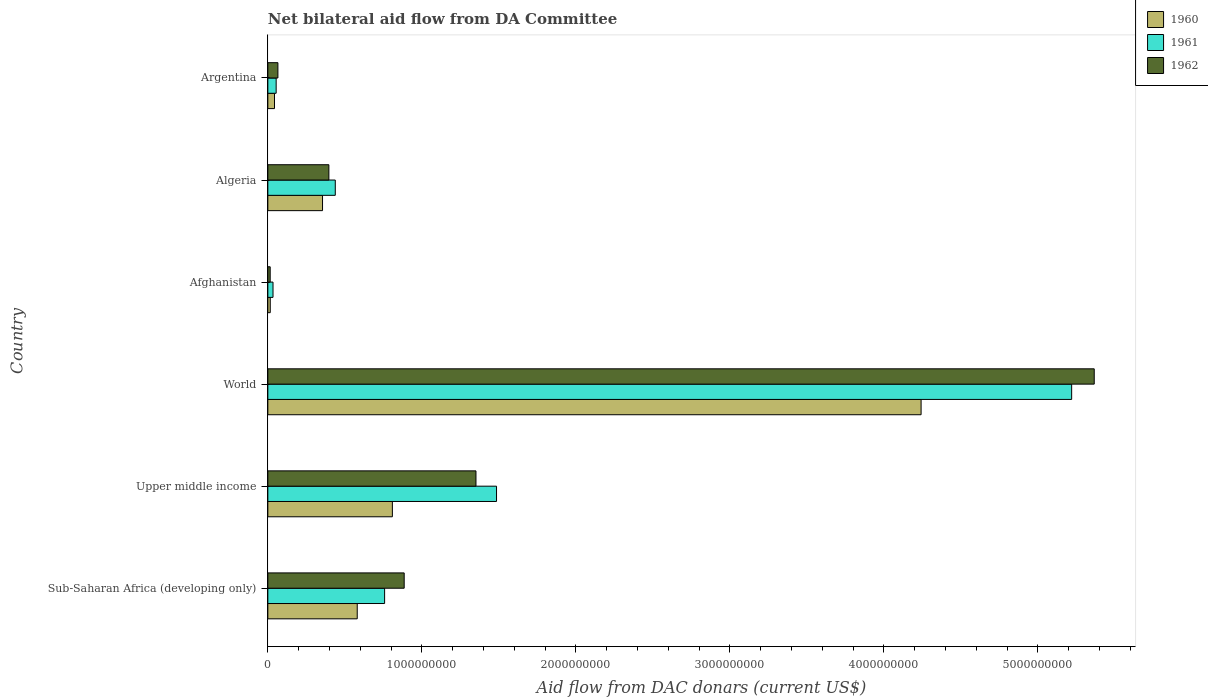How many groups of bars are there?
Give a very brief answer. 6. Are the number of bars per tick equal to the number of legend labels?
Your response must be concise. Yes. Are the number of bars on each tick of the Y-axis equal?
Provide a succinct answer. Yes. How many bars are there on the 6th tick from the top?
Make the answer very short. 3. How many bars are there on the 4th tick from the bottom?
Give a very brief answer. 3. What is the label of the 3rd group of bars from the top?
Provide a short and direct response. Afghanistan. In how many cases, is the number of bars for a given country not equal to the number of legend labels?
Make the answer very short. 0. What is the aid flow in in 1962 in Argentina?
Your answer should be very brief. 6.53e+07. Across all countries, what is the maximum aid flow in in 1962?
Give a very brief answer. 5.37e+09. Across all countries, what is the minimum aid flow in in 1962?
Offer a terse response. 1.53e+07. In which country was the aid flow in in 1960 maximum?
Your answer should be very brief. World. In which country was the aid flow in in 1960 minimum?
Provide a succinct answer. Afghanistan. What is the total aid flow in in 1960 in the graph?
Offer a terse response. 6.04e+09. What is the difference between the aid flow in in 1961 in Afghanistan and that in Argentina?
Your answer should be compact. -2.04e+07. What is the difference between the aid flow in in 1960 in Algeria and the aid flow in in 1961 in Afghanistan?
Provide a short and direct response. 3.22e+08. What is the average aid flow in in 1961 per country?
Your response must be concise. 1.33e+09. What is the difference between the aid flow in in 1960 and aid flow in in 1962 in Upper middle income?
Give a very brief answer. -5.43e+08. In how many countries, is the aid flow in in 1960 greater than 5000000000 US$?
Ensure brevity in your answer.  0. What is the ratio of the aid flow in in 1962 in Afghanistan to that in Upper middle income?
Offer a terse response. 0.01. Is the aid flow in in 1960 in Afghanistan less than that in Sub-Saharan Africa (developing only)?
Your response must be concise. Yes. What is the difference between the highest and the second highest aid flow in in 1961?
Ensure brevity in your answer.  3.73e+09. What is the difference between the highest and the lowest aid flow in in 1960?
Ensure brevity in your answer.  4.23e+09. Is the sum of the aid flow in in 1962 in Sub-Saharan Africa (developing only) and World greater than the maximum aid flow in in 1961 across all countries?
Your answer should be compact. Yes. What does the 1st bar from the top in Upper middle income represents?
Offer a very short reply. 1962. Is it the case that in every country, the sum of the aid flow in in 1960 and aid flow in in 1961 is greater than the aid flow in in 1962?
Provide a succinct answer. Yes. Are all the bars in the graph horizontal?
Provide a short and direct response. Yes. How many countries are there in the graph?
Give a very brief answer. 6. What is the difference between two consecutive major ticks on the X-axis?
Offer a very short reply. 1.00e+09. Does the graph contain any zero values?
Provide a short and direct response. No. Does the graph contain grids?
Provide a succinct answer. No. How many legend labels are there?
Give a very brief answer. 3. How are the legend labels stacked?
Ensure brevity in your answer.  Vertical. What is the title of the graph?
Offer a terse response. Net bilateral aid flow from DA Committee. Does "1987" appear as one of the legend labels in the graph?
Your answer should be very brief. No. What is the label or title of the X-axis?
Keep it short and to the point. Aid flow from DAC donars (current US$). What is the label or title of the Y-axis?
Offer a very short reply. Country. What is the Aid flow from DAC donars (current US$) in 1960 in Sub-Saharan Africa (developing only)?
Keep it short and to the point. 5.80e+08. What is the Aid flow from DAC donars (current US$) of 1961 in Sub-Saharan Africa (developing only)?
Provide a short and direct response. 7.58e+08. What is the Aid flow from DAC donars (current US$) of 1962 in Sub-Saharan Africa (developing only)?
Ensure brevity in your answer.  8.85e+08. What is the Aid flow from DAC donars (current US$) of 1960 in Upper middle income?
Provide a short and direct response. 8.09e+08. What is the Aid flow from DAC donars (current US$) of 1961 in Upper middle income?
Offer a terse response. 1.48e+09. What is the Aid flow from DAC donars (current US$) in 1962 in Upper middle income?
Keep it short and to the point. 1.35e+09. What is the Aid flow from DAC donars (current US$) in 1960 in World?
Offer a very short reply. 4.24e+09. What is the Aid flow from DAC donars (current US$) of 1961 in World?
Keep it short and to the point. 5.22e+09. What is the Aid flow from DAC donars (current US$) in 1962 in World?
Keep it short and to the point. 5.37e+09. What is the Aid flow from DAC donars (current US$) in 1960 in Afghanistan?
Provide a succinct answer. 1.57e+07. What is the Aid flow from DAC donars (current US$) in 1961 in Afghanistan?
Provide a succinct answer. 3.36e+07. What is the Aid flow from DAC donars (current US$) of 1962 in Afghanistan?
Your answer should be very brief. 1.53e+07. What is the Aid flow from DAC donars (current US$) in 1960 in Algeria?
Your response must be concise. 3.55e+08. What is the Aid flow from DAC donars (current US$) of 1961 in Algeria?
Offer a very short reply. 4.38e+08. What is the Aid flow from DAC donars (current US$) in 1962 in Algeria?
Provide a short and direct response. 3.96e+08. What is the Aid flow from DAC donars (current US$) in 1960 in Argentina?
Make the answer very short. 4.32e+07. What is the Aid flow from DAC donars (current US$) of 1961 in Argentina?
Offer a terse response. 5.40e+07. What is the Aid flow from DAC donars (current US$) in 1962 in Argentina?
Give a very brief answer. 6.53e+07. Across all countries, what is the maximum Aid flow from DAC donars (current US$) of 1960?
Keep it short and to the point. 4.24e+09. Across all countries, what is the maximum Aid flow from DAC donars (current US$) in 1961?
Your response must be concise. 5.22e+09. Across all countries, what is the maximum Aid flow from DAC donars (current US$) of 1962?
Your answer should be very brief. 5.37e+09. Across all countries, what is the minimum Aid flow from DAC donars (current US$) of 1960?
Ensure brevity in your answer.  1.57e+07. Across all countries, what is the minimum Aid flow from DAC donars (current US$) in 1961?
Your answer should be very brief. 3.36e+07. Across all countries, what is the minimum Aid flow from DAC donars (current US$) of 1962?
Give a very brief answer. 1.53e+07. What is the total Aid flow from DAC donars (current US$) in 1960 in the graph?
Ensure brevity in your answer.  6.04e+09. What is the total Aid flow from DAC donars (current US$) in 1961 in the graph?
Give a very brief answer. 7.99e+09. What is the total Aid flow from DAC donars (current US$) of 1962 in the graph?
Offer a terse response. 8.08e+09. What is the difference between the Aid flow from DAC donars (current US$) in 1960 in Sub-Saharan Africa (developing only) and that in Upper middle income?
Offer a very short reply. -2.28e+08. What is the difference between the Aid flow from DAC donars (current US$) of 1961 in Sub-Saharan Africa (developing only) and that in Upper middle income?
Your answer should be very brief. -7.27e+08. What is the difference between the Aid flow from DAC donars (current US$) of 1962 in Sub-Saharan Africa (developing only) and that in Upper middle income?
Provide a succinct answer. -4.66e+08. What is the difference between the Aid flow from DAC donars (current US$) in 1960 in Sub-Saharan Africa (developing only) and that in World?
Make the answer very short. -3.66e+09. What is the difference between the Aid flow from DAC donars (current US$) in 1961 in Sub-Saharan Africa (developing only) and that in World?
Offer a terse response. -4.46e+09. What is the difference between the Aid flow from DAC donars (current US$) of 1962 in Sub-Saharan Africa (developing only) and that in World?
Provide a succinct answer. -4.48e+09. What is the difference between the Aid flow from DAC donars (current US$) of 1960 in Sub-Saharan Africa (developing only) and that in Afghanistan?
Your answer should be compact. 5.65e+08. What is the difference between the Aid flow from DAC donars (current US$) of 1961 in Sub-Saharan Africa (developing only) and that in Afghanistan?
Offer a very short reply. 7.25e+08. What is the difference between the Aid flow from DAC donars (current US$) in 1962 in Sub-Saharan Africa (developing only) and that in Afghanistan?
Your response must be concise. 8.70e+08. What is the difference between the Aid flow from DAC donars (current US$) in 1960 in Sub-Saharan Africa (developing only) and that in Algeria?
Provide a succinct answer. 2.25e+08. What is the difference between the Aid flow from DAC donars (current US$) in 1961 in Sub-Saharan Africa (developing only) and that in Algeria?
Your answer should be compact. 3.20e+08. What is the difference between the Aid flow from DAC donars (current US$) in 1962 in Sub-Saharan Africa (developing only) and that in Algeria?
Keep it short and to the point. 4.89e+08. What is the difference between the Aid flow from DAC donars (current US$) of 1960 in Sub-Saharan Africa (developing only) and that in Argentina?
Provide a succinct answer. 5.37e+08. What is the difference between the Aid flow from DAC donars (current US$) in 1961 in Sub-Saharan Africa (developing only) and that in Argentina?
Offer a very short reply. 7.04e+08. What is the difference between the Aid flow from DAC donars (current US$) of 1962 in Sub-Saharan Africa (developing only) and that in Argentina?
Keep it short and to the point. 8.20e+08. What is the difference between the Aid flow from DAC donars (current US$) of 1960 in Upper middle income and that in World?
Offer a very short reply. -3.43e+09. What is the difference between the Aid flow from DAC donars (current US$) in 1961 in Upper middle income and that in World?
Provide a short and direct response. -3.73e+09. What is the difference between the Aid flow from DAC donars (current US$) in 1962 in Upper middle income and that in World?
Provide a succinct answer. -4.01e+09. What is the difference between the Aid flow from DAC donars (current US$) in 1960 in Upper middle income and that in Afghanistan?
Your answer should be very brief. 7.93e+08. What is the difference between the Aid flow from DAC donars (current US$) in 1961 in Upper middle income and that in Afghanistan?
Provide a short and direct response. 1.45e+09. What is the difference between the Aid flow from DAC donars (current US$) of 1962 in Upper middle income and that in Afghanistan?
Provide a succinct answer. 1.34e+09. What is the difference between the Aid flow from DAC donars (current US$) of 1960 in Upper middle income and that in Algeria?
Your answer should be compact. 4.53e+08. What is the difference between the Aid flow from DAC donars (current US$) in 1961 in Upper middle income and that in Algeria?
Provide a short and direct response. 1.05e+09. What is the difference between the Aid flow from DAC donars (current US$) of 1962 in Upper middle income and that in Algeria?
Keep it short and to the point. 9.55e+08. What is the difference between the Aid flow from DAC donars (current US$) in 1960 in Upper middle income and that in Argentina?
Give a very brief answer. 7.65e+08. What is the difference between the Aid flow from DAC donars (current US$) in 1961 in Upper middle income and that in Argentina?
Offer a very short reply. 1.43e+09. What is the difference between the Aid flow from DAC donars (current US$) of 1962 in Upper middle income and that in Argentina?
Ensure brevity in your answer.  1.29e+09. What is the difference between the Aid flow from DAC donars (current US$) of 1960 in World and that in Afghanistan?
Offer a very short reply. 4.23e+09. What is the difference between the Aid flow from DAC donars (current US$) of 1961 in World and that in Afghanistan?
Provide a succinct answer. 5.19e+09. What is the difference between the Aid flow from DAC donars (current US$) in 1962 in World and that in Afghanistan?
Give a very brief answer. 5.35e+09. What is the difference between the Aid flow from DAC donars (current US$) in 1960 in World and that in Algeria?
Your answer should be compact. 3.89e+09. What is the difference between the Aid flow from DAC donars (current US$) of 1961 in World and that in Algeria?
Make the answer very short. 4.78e+09. What is the difference between the Aid flow from DAC donars (current US$) in 1962 in World and that in Algeria?
Your answer should be compact. 4.97e+09. What is the difference between the Aid flow from DAC donars (current US$) in 1960 in World and that in Argentina?
Ensure brevity in your answer.  4.20e+09. What is the difference between the Aid flow from DAC donars (current US$) of 1961 in World and that in Argentina?
Make the answer very short. 5.17e+09. What is the difference between the Aid flow from DAC donars (current US$) in 1962 in World and that in Argentina?
Offer a terse response. 5.30e+09. What is the difference between the Aid flow from DAC donars (current US$) in 1960 in Afghanistan and that in Algeria?
Give a very brief answer. -3.39e+08. What is the difference between the Aid flow from DAC donars (current US$) of 1961 in Afghanistan and that in Algeria?
Offer a very short reply. -4.04e+08. What is the difference between the Aid flow from DAC donars (current US$) in 1962 in Afghanistan and that in Algeria?
Offer a very short reply. -3.81e+08. What is the difference between the Aid flow from DAC donars (current US$) of 1960 in Afghanistan and that in Argentina?
Provide a short and direct response. -2.75e+07. What is the difference between the Aid flow from DAC donars (current US$) of 1961 in Afghanistan and that in Argentina?
Your answer should be very brief. -2.04e+07. What is the difference between the Aid flow from DAC donars (current US$) of 1962 in Afghanistan and that in Argentina?
Your response must be concise. -5.00e+07. What is the difference between the Aid flow from DAC donars (current US$) of 1960 in Algeria and that in Argentina?
Ensure brevity in your answer.  3.12e+08. What is the difference between the Aid flow from DAC donars (current US$) of 1961 in Algeria and that in Argentina?
Give a very brief answer. 3.84e+08. What is the difference between the Aid flow from DAC donars (current US$) of 1962 in Algeria and that in Argentina?
Your answer should be compact. 3.31e+08. What is the difference between the Aid flow from DAC donars (current US$) of 1960 in Sub-Saharan Africa (developing only) and the Aid flow from DAC donars (current US$) of 1961 in Upper middle income?
Keep it short and to the point. -9.05e+08. What is the difference between the Aid flow from DAC donars (current US$) in 1960 in Sub-Saharan Africa (developing only) and the Aid flow from DAC donars (current US$) in 1962 in Upper middle income?
Your response must be concise. -7.71e+08. What is the difference between the Aid flow from DAC donars (current US$) in 1961 in Sub-Saharan Africa (developing only) and the Aid flow from DAC donars (current US$) in 1962 in Upper middle income?
Offer a very short reply. -5.93e+08. What is the difference between the Aid flow from DAC donars (current US$) of 1960 in Sub-Saharan Africa (developing only) and the Aid flow from DAC donars (current US$) of 1961 in World?
Your response must be concise. -4.64e+09. What is the difference between the Aid flow from DAC donars (current US$) of 1960 in Sub-Saharan Africa (developing only) and the Aid flow from DAC donars (current US$) of 1962 in World?
Offer a very short reply. -4.79e+09. What is the difference between the Aid flow from DAC donars (current US$) of 1961 in Sub-Saharan Africa (developing only) and the Aid flow from DAC donars (current US$) of 1962 in World?
Your response must be concise. -4.61e+09. What is the difference between the Aid flow from DAC donars (current US$) in 1960 in Sub-Saharan Africa (developing only) and the Aid flow from DAC donars (current US$) in 1961 in Afghanistan?
Provide a short and direct response. 5.47e+08. What is the difference between the Aid flow from DAC donars (current US$) in 1960 in Sub-Saharan Africa (developing only) and the Aid flow from DAC donars (current US$) in 1962 in Afghanistan?
Your answer should be very brief. 5.65e+08. What is the difference between the Aid flow from DAC donars (current US$) of 1961 in Sub-Saharan Africa (developing only) and the Aid flow from DAC donars (current US$) of 1962 in Afghanistan?
Your answer should be compact. 7.43e+08. What is the difference between the Aid flow from DAC donars (current US$) of 1960 in Sub-Saharan Africa (developing only) and the Aid flow from DAC donars (current US$) of 1961 in Algeria?
Provide a short and direct response. 1.42e+08. What is the difference between the Aid flow from DAC donars (current US$) in 1960 in Sub-Saharan Africa (developing only) and the Aid flow from DAC donars (current US$) in 1962 in Algeria?
Offer a very short reply. 1.84e+08. What is the difference between the Aid flow from DAC donars (current US$) in 1961 in Sub-Saharan Africa (developing only) and the Aid flow from DAC donars (current US$) in 1962 in Algeria?
Keep it short and to the point. 3.62e+08. What is the difference between the Aid flow from DAC donars (current US$) in 1960 in Sub-Saharan Africa (developing only) and the Aid flow from DAC donars (current US$) in 1961 in Argentina?
Your answer should be compact. 5.26e+08. What is the difference between the Aid flow from DAC donars (current US$) in 1960 in Sub-Saharan Africa (developing only) and the Aid flow from DAC donars (current US$) in 1962 in Argentina?
Give a very brief answer. 5.15e+08. What is the difference between the Aid flow from DAC donars (current US$) of 1961 in Sub-Saharan Africa (developing only) and the Aid flow from DAC donars (current US$) of 1962 in Argentina?
Your answer should be very brief. 6.93e+08. What is the difference between the Aid flow from DAC donars (current US$) in 1960 in Upper middle income and the Aid flow from DAC donars (current US$) in 1961 in World?
Provide a short and direct response. -4.41e+09. What is the difference between the Aid flow from DAC donars (current US$) of 1960 in Upper middle income and the Aid flow from DAC donars (current US$) of 1962 in World?
Your answer should be very brief. -4.56e+09. What is the difference between the Aid flow from DAC donars (current US$) of 1961 in Upper middle income and the Aid flow from DAC donars (current US$) of 1962 in World?
Ensure brevity in your answer.  -3.88e+09. What is the difference between the Aid flow from DAC donars (current US$) in 1960 in Upper middle income and the Aid flow from DAC donars (current US$) in 1961 in Afghanistan?
Your response must be concise. 7.75e+08. What is the difference between the Aid flow from DAC donars (current US$) in 1960 in Upper middle income and the Aid flow from DAC donars (current US$) in 1962 in Afghanistan?
Your answer should be compact. 7.93e+08. What is the difference between the Aid flow from DAC donars (current US$) in 1961 in Upper middle income and the Aid flow from DAC donars (current US$) in 1962 in Afghanistan?
Your response must be concise. 1.47e+09. What is the difference between the Aid flow from DAC donars (current US$) in 1960 in Upper middle income and the Aid flow from DAC donars (current US$) in 1961 in Algeria?
Offer a very short reply. 3.71e+08. What is the difference between the Aid flow from DAC donars (current US$) of 1960 in Upper middle income and the Aid flow from DAC donars (current US$) of 1962 in Algeria?
Offer a terse response. 4.12e+08. What is the difference between the Aid flow from DAC donars (current US$) in 1961 in Upper middle income and the Aid flow from DAC donars (current US$) in 1962 in Algeria?
Provide a short and direct response. 1.09e+09. What is the difference between the Aid flow from DAC donars (current US$) of 1960 in Upper middle income and the Aid flow from DAC donars (current US$) of 1961 in Argentina?
Your answer should be compact. 7.55e+08. What is the difference between the Aid flow from DAC donars (current US$) of 1960 in Upper middle income and the Aid flow from DAC donars (current US$) of 1962 in Argentina?
Your answer should be very brief. 7.43e+08. What is the difference between the Aid flow from DAC donars (current US$) of 1961 in Upper middle income and the Aid flow from DAC donars (current US$) of 1962 in Argentina?
Your answer should be compact. 1.42e+09. What is the difference between the Aid flow from DAC donars (current US$) of 1960 in World and the Aid flow from DAC donars (current US$) of 1961 in Afghanistan?
Keep it short and to the point. 4.21e+09. What is the difference between the Aid flow from DAC donars (current US$) of 1960 in World and the Aid flow from DAC donars (current US$) of 1962 in Afghanistan?
Your answer should be compact. 4.23e+09. What is the difference between the Aid flow from DAC donars (current US$) of 1961 in World and the Aid flow from DAC donars (current US$) of 1962 in Afghanistan?
Offer a very short reply. 5.20e+09. What is the difference between the Aid flow from DAC donars (current US$) in 1960 in World and the Aid flow from DAC donars (current US$) in 1961 in Algeria?
Offer a very short reply. 3.80e+09. What is the difference between the Aid flow from DAC donars (current US$) of 1960 in World and the Aid flow from DAC donars (current US$) of 1962 in Algeria?
Give a very brief answer. 3.85e+09. What is the difference between the Aid flow from DAC donars (current US$) in 1961 in World and the Aid flow from DAC donars (current US$) in 1962 in Algeria?
Your answer should be very brief. 4.82e+09. What is the difference between the Aid flow from DAC donars (current US$) in 1960 in World and the Aid flow from DAC donars (current US$) in 1961 in Argentina?
Keep it short and to the point. 4.19e+09. What is the difference between the Aid flow from DAC donars (current US$) of 1960 in World and the Aid flow from DAC donars (current US$) of 1962 in Argentina?
Offer a very short reply. 4.18e+09. What is the difference between the Aid flow from DAC donars (current US$) of 1961 in World and the Aid flow from DAC donars (current US$) of 1962 in Argentina?
Your response must be concise. 5.15e+09. What is the difference between the Aid flow from DAC donars (current US$) of 1960 in Afghanistan and the Aid flow from DAC donars (current US$) of 1961 in Algeria?
Give a very brief answer. -4.22e+08. What is the difference between the Aid flow from DAC donars (current US$) in 1960 in Afghanistan and the Aid flow from DAC donars (current US$) in 1962 in Algeria?
Offer a very short reply. -3.81e+08. What is the difference between the Aid flow from DAC donars (current US$) in 1961 in Afghanistan and the Aid flow from DAC donars (current US$) in 1962 in Algeria?
Keep it short and to the point. -3.63e+08. What is the difference between the Aid flow from DAC donars (current US$) of 1960 in Afghanistan and the Aid flow from DAC donars (current US$) of 1961 in Argentina?
Make the answer very short. -3.83e+07. What is the difference between the Aid flow from DAC donars (current US$) in 1960 in Afghanistan and the Aid flow from DAC donars (current US$) in 1962 in Argentina?
Provide a short and direct response. -4.96e+07. What is the difference between the Aid flow from DAC donars (current US$) of 1961 in Afghanistan and the Aid flow from DAC donars (current US$) of 1962 in Argentina?
Provide a short and direct response. -3.17e+07. What is the difference between the Aid flow from DAC donars (current US$) in 1960 in Algeria and the Aid flow from DAC donars (current US$) in 1961 in Argentina?
Offer a very short reply. 3.01e+08. What is the difference between the Aid flow from DAC donars (current US$) in 1960 in Algeria and the Aid flow from DAC donars (current US$) in 1962 in Argentina?
Give a very brief answer. 2.90e+08. What is the difference between the Aid flow from DAC donars (current US$) of 1961 in Algeria and the Aid flow from DAC donars (current US$) of 1962 in Argentina?
Make the answer very short. 3.73e+08. What is the average Aid flow from DAC donars (current US$) of 1960 per country?
Your response must be concise. 1.01e+09. What is the average Aid flow from DAC donars (current US$) in 1961 per country?
Make the answer very short. 1.33e+09. What is the average Aid flow from DAC donars (current US$) of 1962 per country?
Give a very brief answer. 1.35e+09. What is the difference between the Aid flow from DAC donars (current US$) in 1960 and Aid flow from DAC donars (current US$) in 1961 in Sub-Saharan Africa (developing only)?
Give a very brief answer. -1.78e+08. What is the difference between the Aid flow from DAC donars (current US$) of 1960 and Aid flow from DAC donars (current US$) of 1962 in Sub-Saharan Africa (developing only)?
Keep it short and to the point. -3.05e+08. What is the difference between the Aid flow from DAC donars (current US$) in 1961 and Aid flow from DAC donars (current US$) in 1962 in Sub-Saharan Africa (developing only)?
Your answer should be very brief. -1.27e+08. What is the difference between the Aid flow from DAC donars (current US$) in 1960 and Aid flow from DAC donars (current US$) in 1961 in Upper middle income?
Make the answer very short. -6.76e+08. What is the difference between the Aid flow from DAC donars (current US$) in 1960 and Aid flow from DAC donars (current US$) in 1962 in Upper middle income?
Ensure brevity in your answer.  -5.43e+08. What is the difference between the Aid flow from DAC donars (current US$) in 1961 and Aid flow from DAC donars (current US$) in 1962 in Upper middle income?
Ensure brevity in your answer.  1.34e+08. What is the difference between the Aid flow from DAC donars (current US$) of 1960 and Aid flow from DAC donars (current US$) of 1961 in World?
Provide a succinct answer. -9.78e+08. What is the difference between the Aid flow from DAC donars (current US$) in 1960 and Aid flow from DAC donars (current US$) in 1962 in World?
Provide a succinct answer. -1.12e+09. What is the difference between the Aid flow from DAC donars (current US$) in 1961 and Aid flow from DAC donars (current US$) in 1962 in World?
Keep it short and to the point. -1.47e+08. What is the difference between the Aid flow from DAC donars (current US$) in 1960 and Aid flow from DAC donars (current US$) in 1961 in Afghanistan?
Make the answer very short. -1.79e+07. What is the difference between the Aid flow from DAC donars (current US$) of 1961 and Aid flow from DAC donars (current US$) of 1962 in Afghanistan?
Keep it short and to the point. 1.83e+07. What is the difference between the Aid flow from DAC donars (current US$) of 1960 and Aid flow from DAC donars (current US$) of 1961 in Algeria?
Your response must be concise. -8.28e+07. What is the difference between the Aid flow from DAC donars (current US$) in 1960 and Aid flow from DAC donars (current US$) in 1962 in Algeria?
Provide a succinct answer. -4.12e+07. What is the difference between the Aid flow from DAC donars (current US$) of 1961 and Aid flow from DAC donars (current US$) of 1962 in Algeria?
Keep it short and to the point. 4.16e+07. What is the difference between the Aid flow from DAC donars (current US$) in 1960 and Aid flow from DAC donars (current US$) in 1961 in Argentina?
Ensure brevity in your answer.  -1.07e+07. What is the difference between the Aid flow from DAC donars (current US$) of 1960 and Aid flow from DAC donars (current US$) of 1962 in Argentina?
Keep it short and to the point. -2.21e+07. What is the difference between the Aid flow from DAC donars (current US$) in 1961 and Aid flow from DAC donars (current US$) in 1962 in Argentina?
Provide a succinct answer. -1.13e+07. What is the ratio of the Aid flow from DAC donars (current US$) in 1960 in Sub-Saharan Africa (developing only) to that in Upper middle income?
Offer a very short reply. 0.72. What is the ratio of the Aid flow from DAC donars (current US$) of 1961 in Sub-Saharan Africa (developing only) to that in Upper middle income?
Keep it short and to the point. 0.51. What is the ratio of the Aid flow from DAC donars (current US$) of 1962 in Sub-Saharan Africa (developing only) to that in Upper middle income?
Ensure brevity in your answer.  0.66. What is the ratio of the Aid flow from DAC donars (current US$) in 1960 in Sub-Saharan Africa (developing only) to that in World?
Offer a very short reply. 0.14. What is the ratio of the Aid flow from DAC donars (current US$) of 1961 in Sub-Saharan Africa (developing only) to that in World?
Offer a very short reply. 0.15. What is the ratio of the Aid flow from DAC donars (current US$) in 1962 in Sub-Saharan Africa (developing only) to that in World?
Your answer should be compact. 0.17. What is the ratio of the Aid flow from DAC donars (current US$) in 1960 in Sub-Saharan Africa (developing only) to that in Afghanistan?
Ensure brevity in your answer.  37.04. What is the ratio of the Aid flow from DAC donars (current US$) in 1961 in Sub-Saharan Africa (developing only) to that in Afghanistan?
Your answer should be very brief. 22.6. What is the ratio of the Aid flow from DAC donars (current US$) of 1962 in Sub-Saharan Africa (developing only) to that in Afghanistan?
Offer a terse response. 58.01. What is the ratio of the Aid flow from DAC donars (current US$) in 1960 in Sub-Saharan Africa (developing only) to that in Algeria?
Your answer should be very brief. 1.63. What is the ratio of the Aid flow from DAC donars (current US$) of 1961 in Sub-Saharan Africa (developing only) to that in Algeria?
Ensure brevity in your answer.  1.73. What is the ratio of the Aid flow from DAC donars (current US$) of 1962 in Sub-Saharan Africa (developing only) to that in Algeria?
Offer a terse response. 2.23. What is the ratio of the Aid flow from DAC donars (current US$) in 1960 in Sub-Saharan Africa (developing only) to that in Argentina?
Provide a short and direct response. 13.43. What is the ratio of the Aid flow from DAC donars (current US$) of 1961 in Sub-Saharan Africa (developing only) to that in Argentina?
Give a very brief answer. 14.05. What is the ratio of the Aid flow from DAC donars (current US$) of 1962 in Sub-Saharan Africa (developing only) to that in Argentina?
Give a very brief answer. 13.56. What is the ratio of the Aid flow from DAC donars (current US$) in 1960 in Upper middle income to that in World?
Give a very brief answer. 0.19. What is the ratio of the Aid flow from DAC donars (current US$) in 1961 in Upper middle income to that in World?
Give a very brief answer. 0.28. What is the ratio of the Aid flow from DAC donars (current US$) of 1962 in Upper middle income to that in World?
Your answer should be compact. 0.25. What is the ratio of the Aid flow from DAC donars (current US$) in 1960 in Upper middle income to that in Afghanistan?
Your answer should be compact. 51.6. What is the ratio of the Aid flow from DAC donars (current US$) in 1961 in Upper middle income to that in Afghanistan?
Provide a succinct answer. 44.26. What is the ratio of the Aid flow from DAC donars (current US$) in 1962 in Upper middle income to that in Afghanistan?
Offer a terse response. 88.56. What is the ratio of the Aid flow from DAC donars (current US$) of 1960 in Upper middle income to that in Algeria?
Offer a very short reply. 2.28. What is the ratio of the Aid flow from DAC donars (current US$) of 1961 in Upper middle income to that in Algeria?
Keep it short and to the point. 3.39. What is the ratio of the Aid flow from DAC donars (current US$) in 1962 in Upper middle income to that in Algeria?
Your answer should be compact. 3.41. What is the ratio of the Aid flow from DAC donars (current US$) in 1960 in Upper middle income to that in Argentina?
Offer a terse response. 18.71. What is the ratio of the Aid flow from DAC donars (current US$) of 1961 in Upper middle income to that in Argentina?
Provide a short and direct response. 27.52. What is the ratio of the Aid flow from DAC donars (current US$) in 1962 in Upper middle income to that in Argentina?
Offer a very short reply. 20.7. What is the ratio of the Aid flow from DAC donars (current US$) of 1960 in World to that in Afghanistan?
Your answer should be very brief. 270.67. What is the ratio of the Aid flow from DAC donars (current US$) in 1961 in World to that in Afghanistan?
Keep it short and to the point. 155.56. What is the ratio of the Aid flow from DAC donars (current US$) of 1962 in World to that in Afghanistan?
Your answer should be compact. 351.61. What is the ratio of the Aid flow from DAC donars (current US$) of 1960 in World to that in Algeria?
Your response must be concise. 11.94. What is the ratio of the Aid flow from DAC donars (current US$) of 1961 in World to that in Algeria?
Your response must be concise. 11.92. What is the ratio of the Aid flow from DAC donars (current US$) in 1962 in World to that in Algeria?
Your response must be concise. 13.54. What is the ratio of the Aid flow from DAC donars (current US$) in 1960 in World to that in Argentina?
Your response must be concise. 98.16. What is the ratio of the Aid flow from DAC donars (current US$) in 1961 in World to that in Argentina?
Give a very brief answer. 96.74. What is the ratio of the Aid flow from DAC donars (current US$) in 1962 in World to that in Argentina?
Offer a terse response. 82.18. What is the ratio of the Aid flow from DAC donars (current US$) in 1960 in Afghanistan to that in Algeria?
Ensure brevity in your answer.  0.04. What is the ratio of the Aid flow from DAC donars (current US$) in 1961 in Afghanistan to that in Algeria?
Give a very brief answer. 0.08. What is the ratio of the Aid flow from DAC donars (current US$) in 1962 in Afghanistan to that in Algeria?
Provide a succinct answer. 0.04. What is the ratio of the Aid flow from DAC donars (current US$) of 1960 in Afghanistan to that in Argentina?
Your answer should be compact. 0.36. What is the ratio of the Aid flow from DAC donars (current US$) of 1961 in Afghanistan to that in Argentina?
Keep it short and to the point. 0.62. What is the ratio of the Aid flow from DAC donars (current US$) in 1962 in Afghanistan to that in Argentina?
Keep it short and to the point. 0.23. What is the ratio of the Aid flow from DAC donars (current US$) of 1960 in Algeria to that in Argentina?
Provide a short and direct response. 8.22. What is the ratio of the Aid flow from DAC donars (current US$) of 1961 in Algeria to that in Argentina?
Provide a short and direct response. 8.12. What is the ratio of the Aid flow from DAC donars (current US$) in 1962 in Algeria to that in Argentina?
Ensure brevity in your answer.  6.07. What is the difference between the highest and the second highest Aid flow from DAC donars (current US$) in 1960?
Your response must be concise. 3.43e+09. What is the difference between the highest and the second highest Aid flow from DAC donars (current US$) of 1961?
Ensure brevity in your answer.  3.73e+09. What is the difference between the highest and the second highest Aid flow from DAC donars (current US$) in 1962?
Give a very brief answer. 4.01e+09. What is the difference between the highest and the lowest Aid flow from DAC donars (current US$) in 1960?
Your response must be concise. 4.23e+09. What is the difference between the highest and the lowest Aid flow from DAC donars (current US$) in 1961?
Ensure brevity in your answer.  5.19e+09. What is the difference between the highest and the lowest Aid flow from DAC donars (current US$) in 1962?
Make the answer very short. 5.35e+09. 